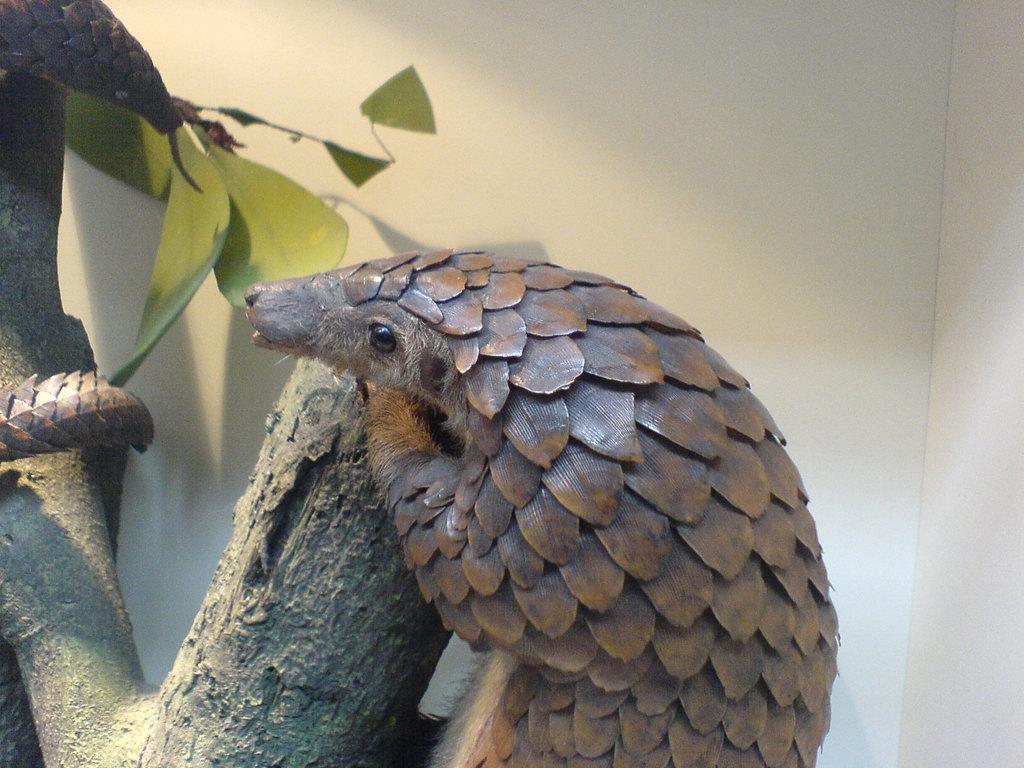Please provide a concise description of this image. In this picture, we see an animal or a bird in brown color, is on the tree. Behind that, we see a wall which is white in color. 